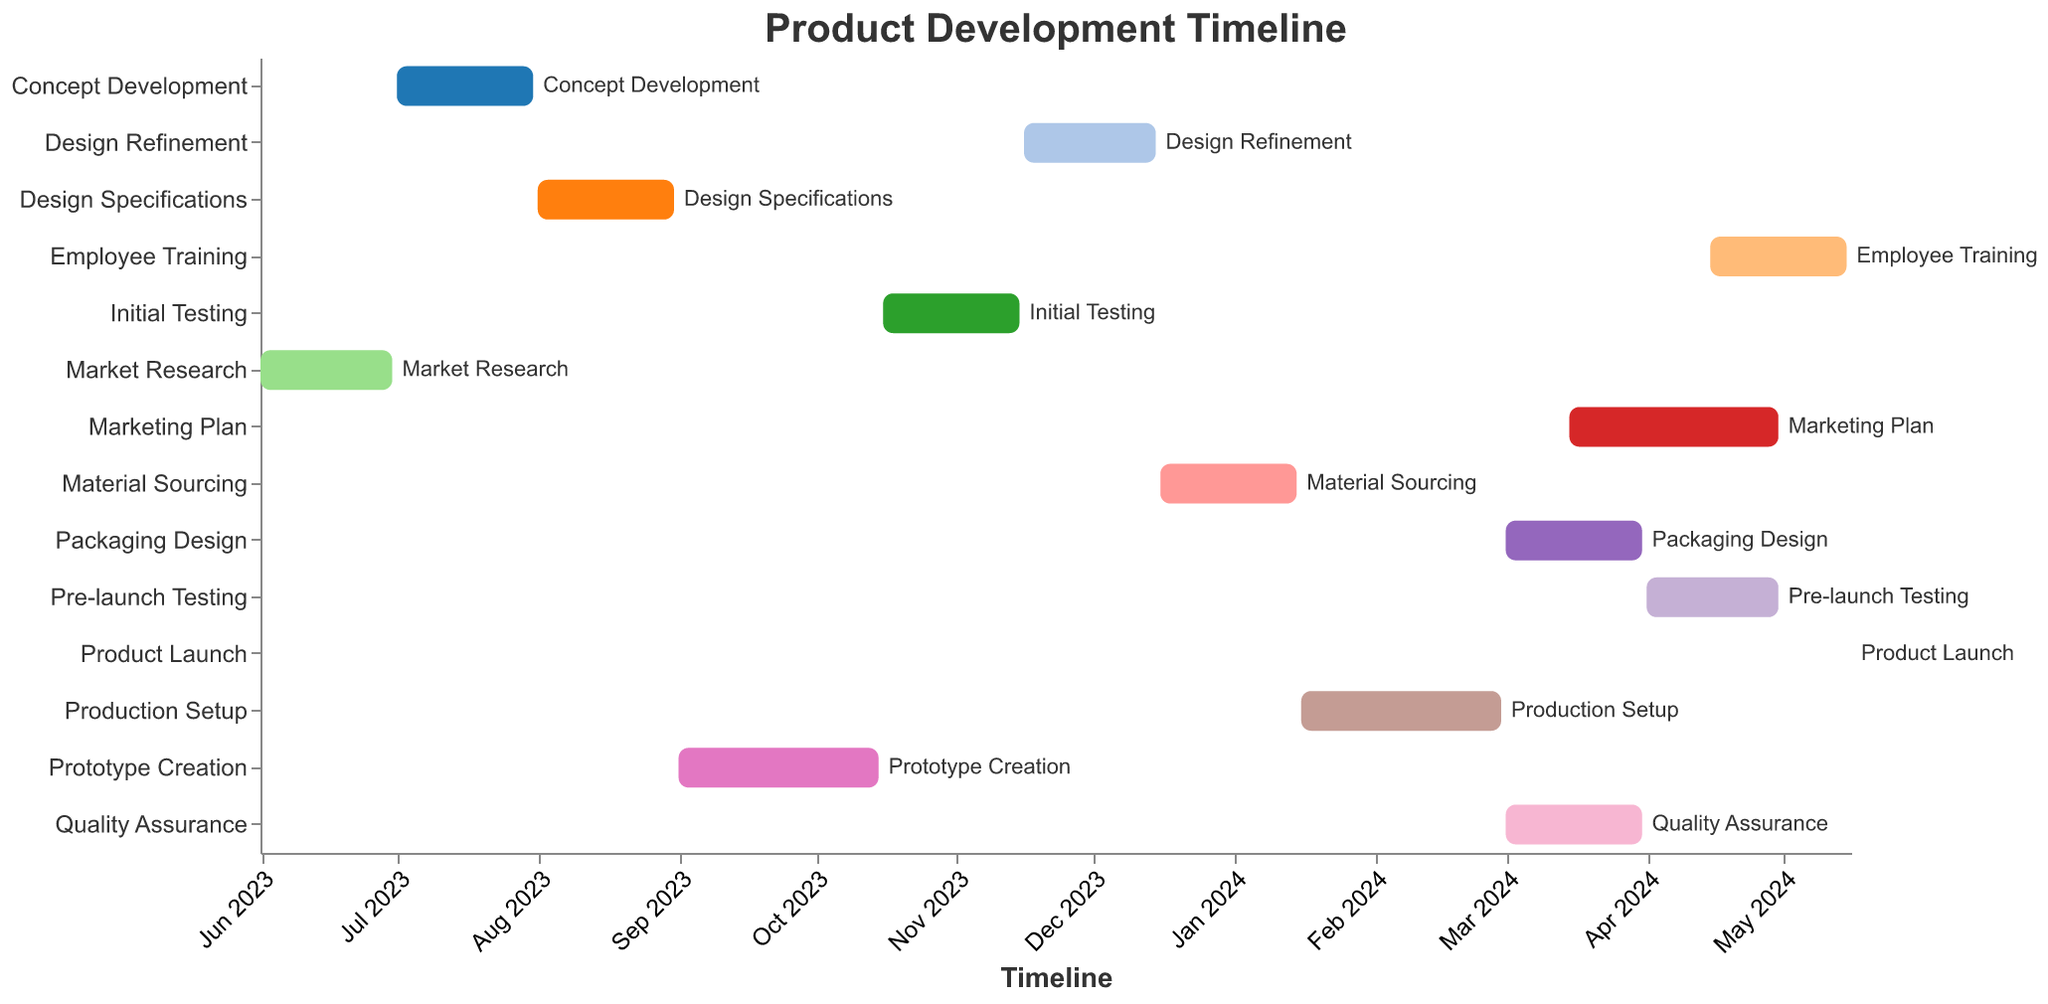What's the title of the Gantt Chart? The title is usually found at the top of the chart and provides an overall description of the visualized data. The title here is "Product Development Timeline"
Answer: Product Development Timeline How many phases are included in the Product Development Timeline? Count the number of different tasks or bars in the chart, each representing a phase of the product development process. There are 14 tasks listed.
Answer: 14 Which phase lasts the shortest amount of time? By looking at the length of each bar, identify the shortest one. The "Product Launch" phase starts and ends on the same day, making it the shortest phase.
Answer: Product Launch Which phases overlap with "Quality Assurance"? Find the time period for "Quality Assurance" (March 1, 2024 - March 31, 2024) and see which other tasks fall within that range. "Packaging Design" (March 1, 2024 - March 31, 2024) and "Marketing Plan" (March 15, 2024 - April 30, 2024) overlap with "Quality Assurance".
Answer: Packaging Design, Marketing Plan What's the duration of the "Prototype Creation" phase? Calculate the difference between the start and end dates of the "Prototype Creation" phase. From September 1, 2023 to October 15, 2023, the total duration is 45 days.
Answer: 45 days Which phase directly follows "Initial Testing"? Identify the sequence of tasks based on their dates. The task that starts right after "Initial Testing" (October 16, 2023 - November 15, 2023) is "Design Refinement" (November 16, 2023 - December 15, 2023).
Answer: Design Refinement How many phases are planned to be executed after "Material Sourcing"? Count the number of phases that start after "Material Sourcing" ends on January 15, 2024. There are 6 remaining tasks: "Production Setup", "Quality Assurance", "Packaging Design", "Marketing Plan", "Pre-launch Testing", and "Employee Training".
Answer: 6 Which phase has the most extended duration, and what is the timespan? Look at each phase's start and end dates and calculate the duration. The "Production Setup" phase has the longest duration from January 16, 2024, to February 29, 2024, which is 45 days.
Answer: Production Setup, 45 days During which phase do both "Pre-launch Testing" and "Employee Training" occur? Check the overlapping time period between "Pre-launch Testing" (April 1, 2024 - April 30, 2024) and "Employee Training" (April 15, 2024 - May 15, 2024). They both overlap during the time from April 15, 2024, to April 30, 2024.
Answer: April 15, 2024 - April 30, 2024 